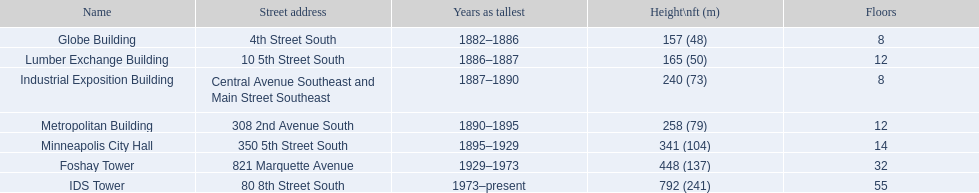In which buildings can you find the same quantity of floors as in another building? Globe Building, Lumber Exchange Building, Industrial Exposition Building, Metropolitan Building. Out of these, which has an identical count as the lumber exchange building? Metropolitan Building. 